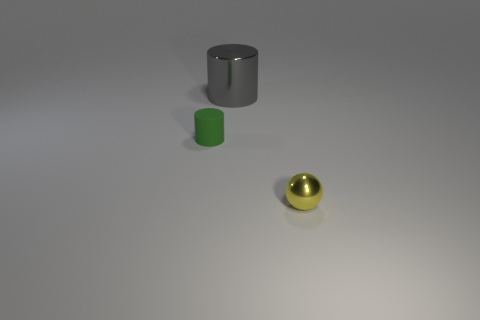Add 2 large gray shiny cylinders. How many objects exist? 5 Subtract all spheres. How many objects are left? 2 Subtract 1 gray cylinders. How many objects are left? 2 Subtract all yellow metallic things. Subtract all purple rubber cylinders. How many objects are left? 2 Add 2 tiny green matte things. How many tiny green matte things are left? 3 Add 2 big metallic cylinders. How many big metallic cylinders exist? 3 